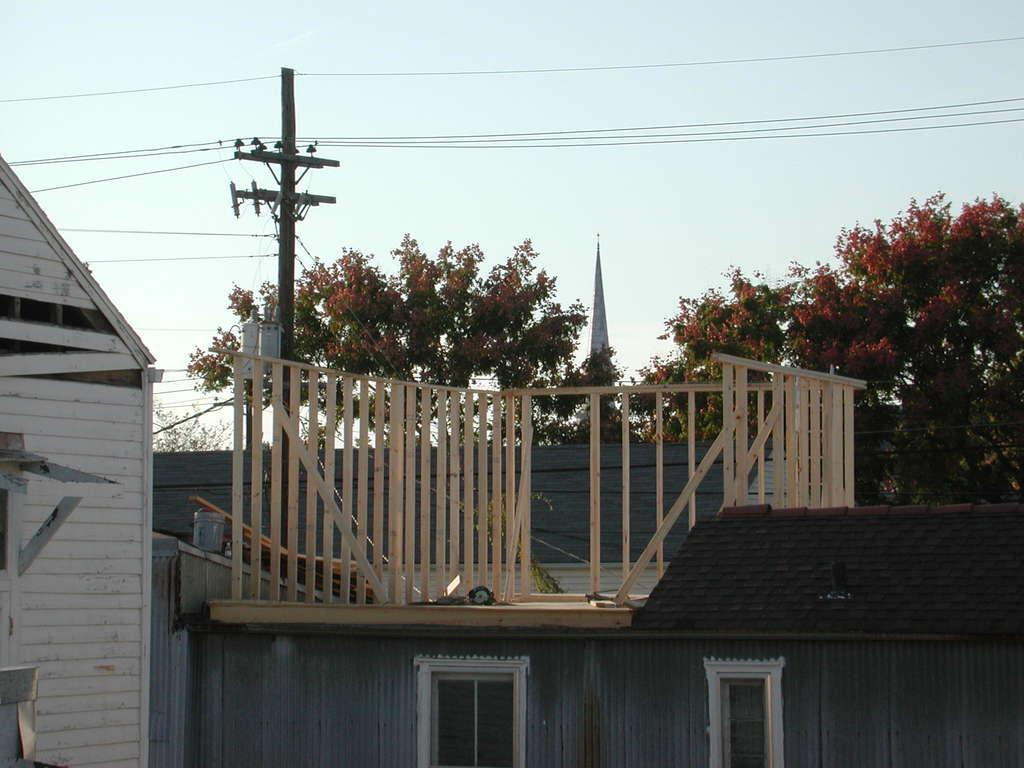What type of structures are visible in the image? There are houses with windows in the image. What else can be seen in the image besides the houses? There is an electrical pole with wires in the image. What is visible in the background of the image? There are trees and the sky in the background of the image. What type of juice is being served in the carriage in the image? There is no carriage or juice present in the image. 